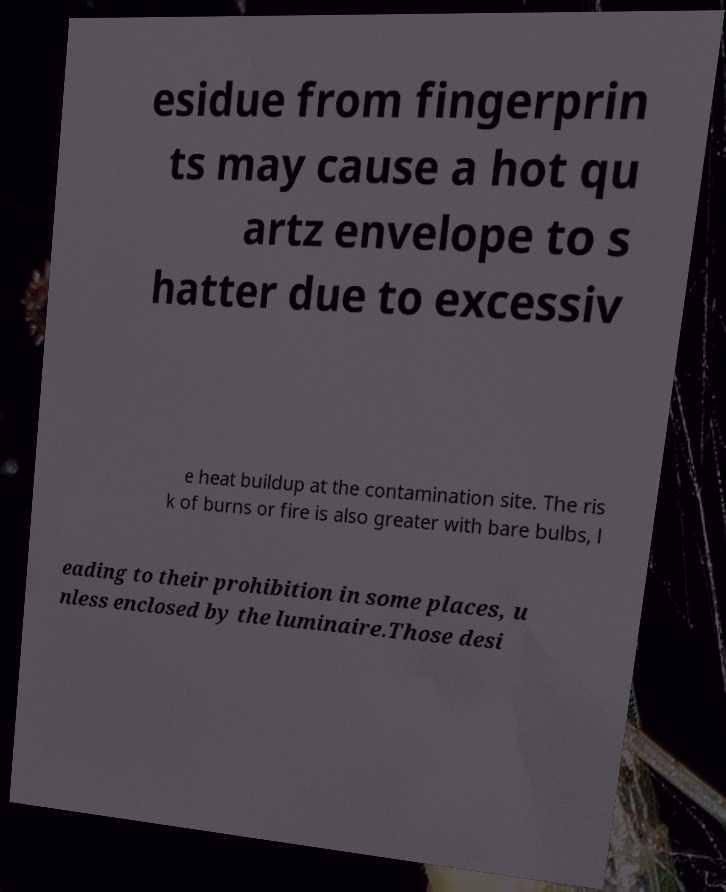Please read and relay the text visible in this image. What does it say? esidue from fingerprin ts may cause a hot qu artz envelope to s hatter due to excessiv e heat buildup at the contamination site. The ris k of burns or fire is also greater with bare bulbs, l eading to their prohibition in some places, u nless enclosed by the luminaire.Those desi 